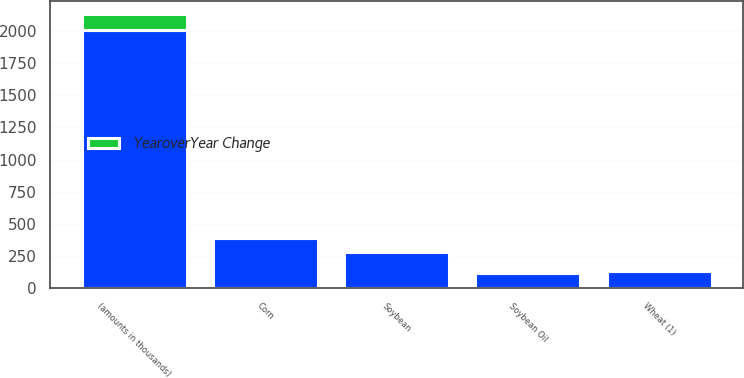Convert chart to OTSL. <chart><loc_0><loc_0><loc_500><loc_500><stacked_bar_chart><ecel><fcel>(amounts in thousands)<fcel>Corn<fcel>Soybean<fcel>Wheat (1)<fcel>Soybean Oil<nl><fcel>nan<fcel>2012<fcel>392<fcel>278<fcel>129<fcel>118<nl><fcel>YearoverYear Change<fcel>118<fcel>8<fcel>20<fcel>12<fcel>12<nl></chart> 